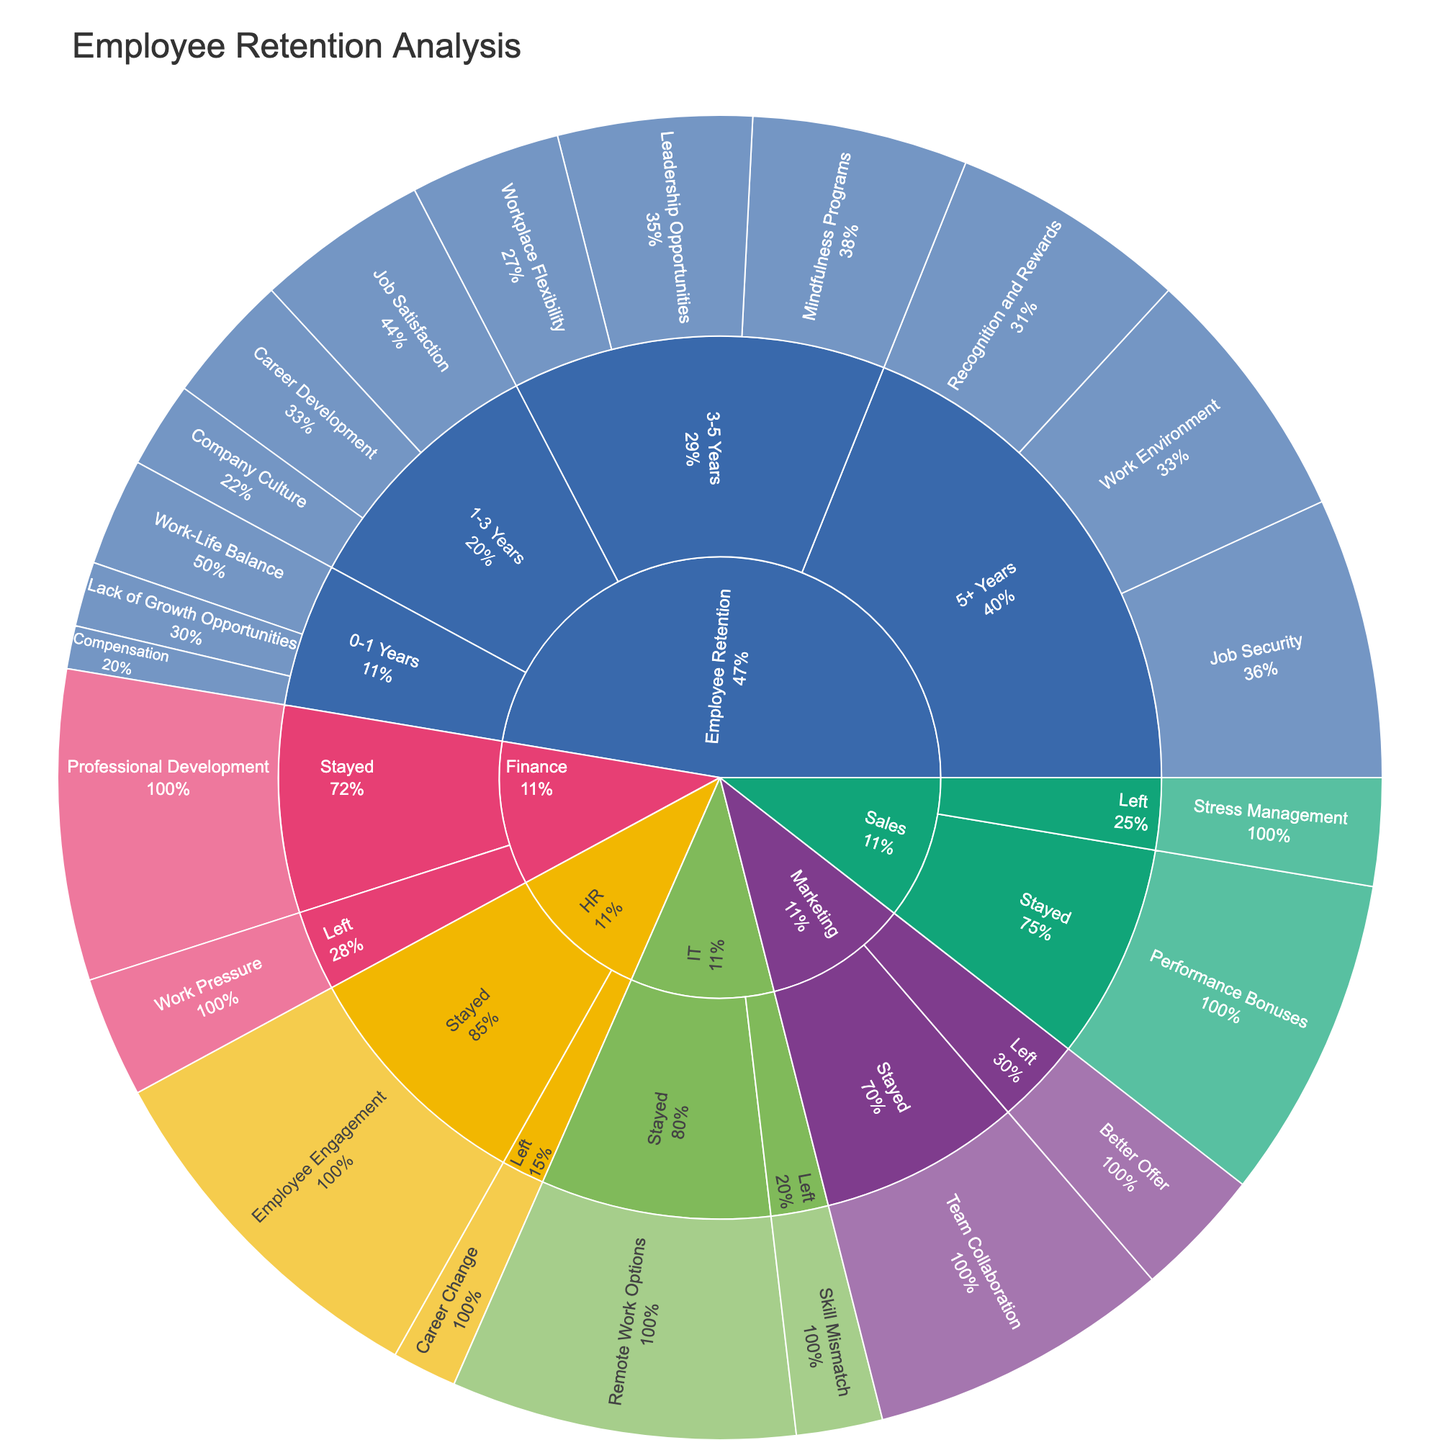What's the title of the plot? The title of the plot is displayed at the top and directly observable.
Answer: Employee Retention Analysis Which tenure category has the highest value for reasons for staying? We need to look at the 'Stayed' subcategories under each tenure category and compare their values.
Answer: HR with 85 What's the difference in values between reasons for staying and leaving in the Marketing department? Subtract the 'Left' value from the 'Stayed' value under the Marketing department. Stayed (70) - Left (30) = 40.
Answer: 40 Which category has received attention for including mindfulness programs? The category and reason associated with 'Mindfulness Programs' can be located within the plot.
Answer: Employee Retention (3-5 Years) What is the combined value for reasons related to 'Compensation' and 'Work-Life Balance' in the 0-1 Years tenure category? Sum up the values for 'Compensation' and 'Work-Life Balance' under the 0-1 Years subcategory. 10 + 25 = 35.
Answer: 35 In the Employee Retention category, which tenure subcategory has the lowest total value for any reason? Compare the total values listed for each tenure subcategory in the Employee Retention category.
Answer: 0-1 Years Is the value of 'Recognition and Rewards' in the 5+ Years tenure category greater than 'Leadership Opportunities' in the 3-5 Years tenure category? Compare the values of 'Recognition and Rewards' under 5+ Years with 'Leadership Opportunities' under 3-5 Years. 55 vs 45.
Answer: Yes Which category and subcategory combined have the highest value for reasons of 'Job Satisfaction'? Locate the value for 'Job Satisfaction' and identify the associated category and subcategory.
Answer: Employee Retention (1-3 Years) 